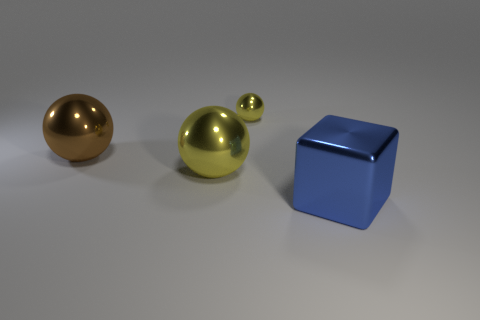How many big objects are the same shape as the tiny yellow metallic thing?
Make the answer very short. 2. Do the brown shiny thing and the small yellow metal object have the same shape?
Provide a short and direct response. Yes. Is there another metallic thing that has the same color as the small metallic thing?
Make the answer very short. Yes. Is the number of yellow spheres right of the metallic cube the same as the number of blue cylinders?
Your answer should be very brief. Yes. What color is the big shiny sphere on the right side of the brown sphere?
Provide a short and direct response. Yellow. Are there any other things that have the same shape as the blue object?
Ensure brevity in your answer.  No. How big is the shiny sphere on the right side of the ball that is in front of the large brown sphere?
Make the answer very short. Small. Are there an equal number of tiny spheres behind the tiny thing and tiny yellow things that are to the left of the big yellow metal sphere?
Keep it short and to the point. Yes. Are there any other things that are the same size as the blue block?
Provide a succinct answer. Yes. What is the color of the block that is made of the same material as the tiny sphere?
Offer a terse response. Blue. 